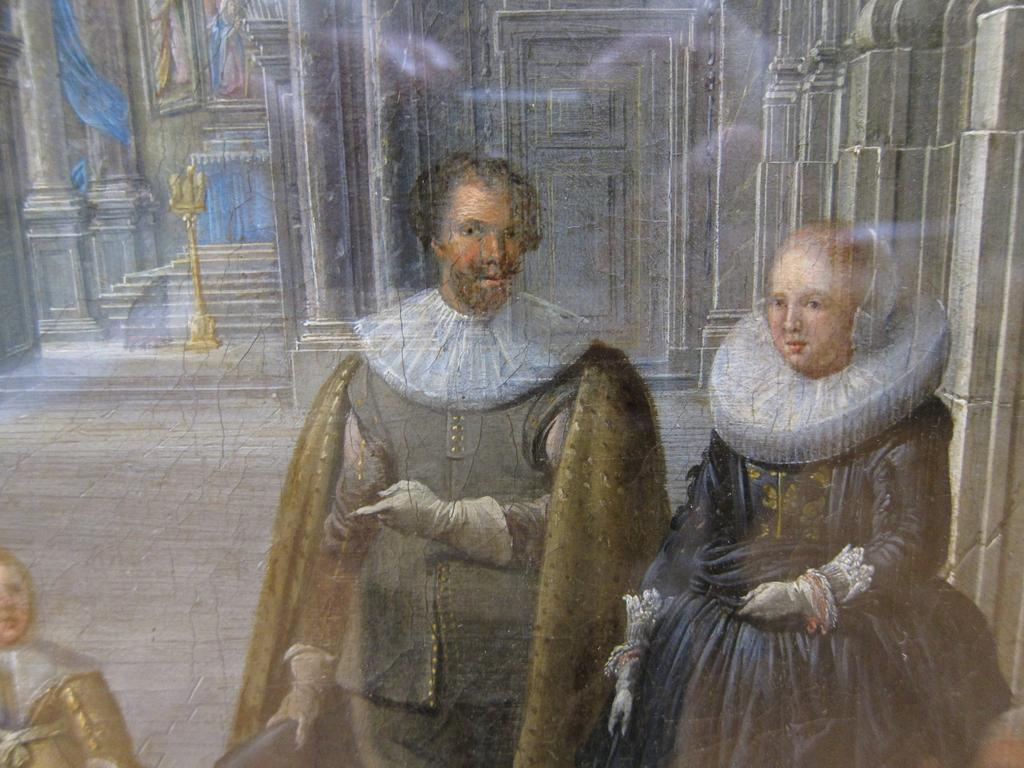What types of people are depicted in the painting? The painting contains a man, a woman, and a child. What type of interior elements are present in the painting? The painting contains curtains and doors. What type of chain can be seen hanging from the child's ear in the painting? There is no chain or earring visible on the child in the painting. 